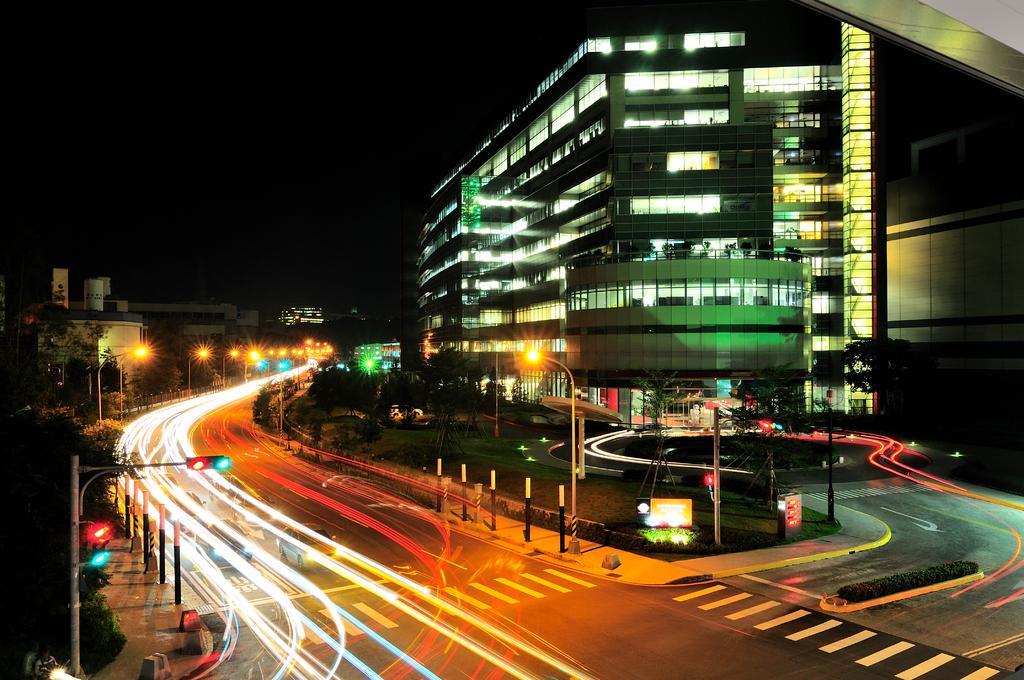Please provide a concise description of this image. In this image, on the right side, we can see a glass building, trees. In the middle of the image, we can see a street light. On the left side, we can see a traffic signal, trees. In the middle of the image, we can see a road and lights. In the background, we can see some lights, building, trees. At the top, we can see black color, at the bottom, we can see a road with few lights. 